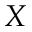Convert formula to latex. <formula><loc_0><loc_0><loc_500><loc_500>X</formula> 